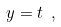<formula> <loc_0><loc_0><loc_500><loc_500>y = t \ ,</formula> 